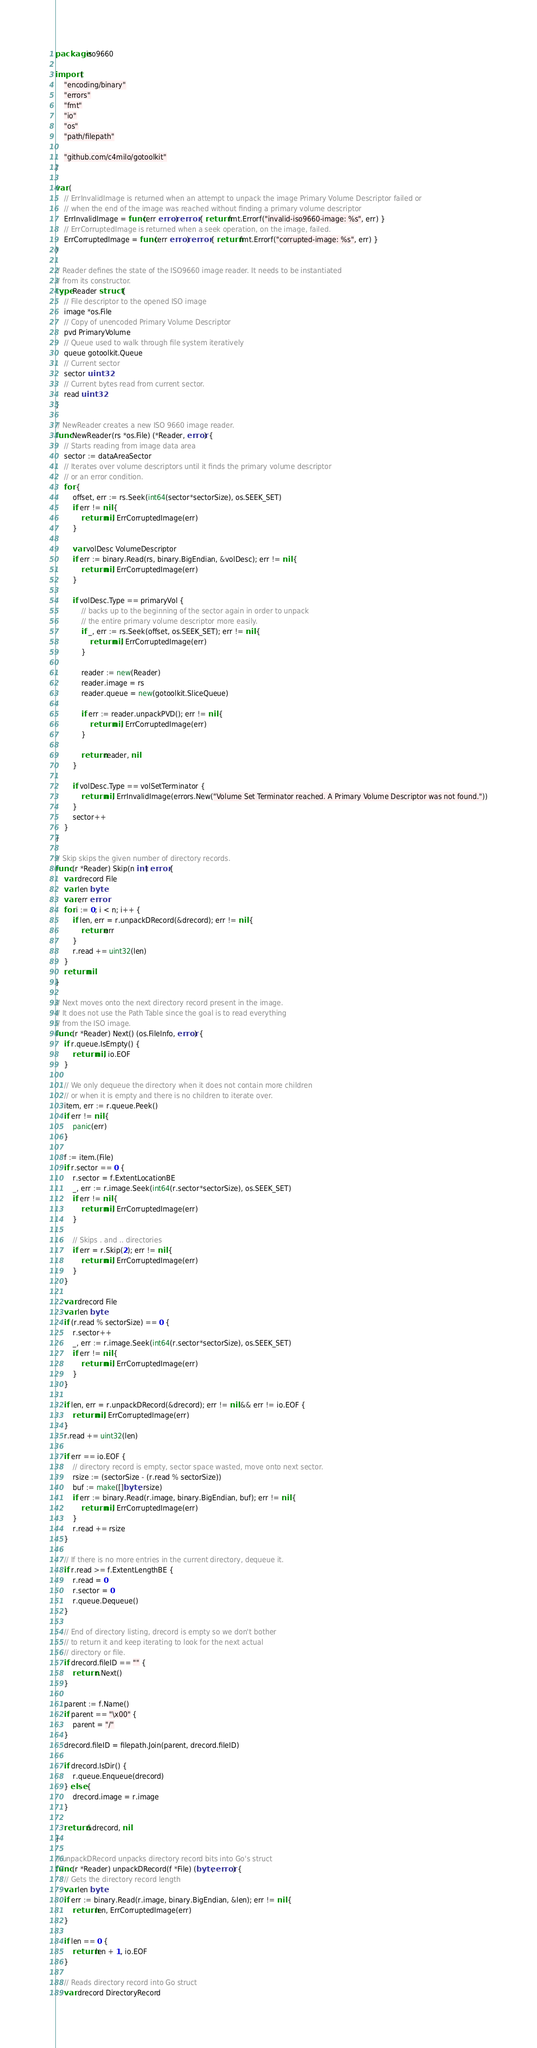Convert code to text. <code><loc_0><loc_0><loc_500><loc_500><_Go_>package iso9660

import (
	"encoding/binary"
	"errors"
	"fmt"
	"io"
	"os"
	"path/filepath"

	"github.com/c4milo/gotoolkit"
)

var (
	// ErrInvalidImage is returned when an attempt to unpack the image Primary Volume Descriptor failed or
	// when the end of the image was reached without finding a primary volume descriptor
	ErrInvalidImage = func(err error) error { return fmt.Errorf("invalid-iso9660-image: %s", err) }
	// ErrCorruptedImage is returned when a seek operation, on the image, failed.
	ErrCorruptedImage = func(err error) error { return fmt.Errorf("corrupted-image: %s", err) }
)

// Reader defines the state of the ISO9660 image reader. It needs to be instantiated
// from its constructor.
type Reader struct {
	// File descriptor to the opened ISO image
	image *os.File
	// Copy of unencoded Primary Volume Descriptor
	pvd PrimaryVolume
	// Queue used to walk through file system iteratively
	queue gotoolkit.Queue
	// Current sector
	sector uint32
	// Current bytes read from current sector.
	read uint32
}

// NewReader creates a new ISO 9660 image reader.
func NewReader(rs *os.File) (*Reader, error) {
	// Starts reading from image data area
	sector := dataAreaSector
	// Iterates over volume descriptors until it finds the primary volume descriptor
	// or an error condition.
	for {
		offset, err := rs.Seek(int64(sector*sectorSize), os.SEEK_SET)
		if err != nil {
			return nil, ErrCorruptedImage(err)
		}

		var volDesc VolumeDescriptor
		if err := binary.Read(rs, binary.BigEndian, &volDesc); err != nil {
			return nil, ErrCorruptedImage(err)
		}

		if volDesc.Type == primaryVol {
			// backs up to the beginning of the sector again in order to unpack
			// the entire primary volume descriptor more easily.
			if _, err := rs.Seek(offset, os.SEEK_SET); err != nil {
				return nil, ErrCorruptedImage(err)
			}

			reader := new(Reader)
			reader.image = rs
			reader.queue = new(gotoolkit.SliceQueue)

			if err := reader.unpackPVD(); err != nil {
				return nil, ErrCorruptedImage(err)
			}

			return reader, nil
		}

		if volDesc.Type == volSetTerminator {
			return nil, ErrInvalidImage(errors.New("Volume Set Terminator reached. A Primary Volume Descriptor was not found."))
		}
		sector++
	}
}

// Skip skips the given number of directory records.
func (r *Reader) Skip(n int) error {
	var drecord File
	var len byte
	var err error
	for i := 0; i < n; i++ {
		if len, err = r.unpackDRecord(&drecord); err != nil {
			return err
		}
		r.read += uint32(len)
	}
	return nil
}

// Next moves onto the next directory record present in the image.
// It does not use the Path Table since the goal is to read everything
// from the ISO image.
func (r *Reader) Next() (os.FileInfo, error) {
	if r.queue.IsEmpty() {
		return nil, io.EOF
	}

	// We only dequeue the directory when it does not contain more children
	// or when it is empty and there is no children to iterate over.
	item, err := r.queue.Peek()
	if err != nil {
		panic(err)
	}

	f := item.(File)
	if r.sector == 0 {
		r.sector = f.ExtentLocationBE
		_, err := r.image.Seek(int64(r.sector*sectorSize), os.SEEK_SET)
		if err != nil {
			return nil, ErrCorruptedImage(err)
		}

		// Skips . and .. directories
		if err = r.Skip(2); err != nil {
			return nil, ErrCorruptedImage(err)
		}
	}

	var drecord File
	var len byte
	if (r.read % sectorSize) == 0 {
		r.sector++
		_, err := r.image.Seek(int64(r.sector*sectorSize), os.SEEK_SET)
		if err != nil {
			return nil, ErrCorruptedImage(err)
		}
	}

	if len, err = r.unpackDRecord(&drecord); err != nil && err != io.EOF {
		return nil, ErrCorruptedImage(err)
	}
	r.read += uint32(len)

	if err == io.EOF {
		// directory record is empty, sector space wasted, move onto next sector.
		rsize := (sectorSize - (r.read % sectorSize))
		buf := make([]byte, rsize)
		if err := binary.Read(r.image, binary.BigEndian, buf); err != nil {
			return nil, ErrCorruptedImage(err)
		}
		r.read += rsize
	}

	// If there is no more entries in the current directory, dequeue it.
	if r.read >= f.ExtentLengthBE {
		r.read = 0
		r.sector = 0
		r.queue.Dequeue()
	}

	// End of directory listing, drecord is empty so we don't bother
	// to return it and keep iterating to look for the next actual
	// directory or file.
	if drecord.fileID == "" {
		return r.Next()
	}

	parent := f.Name()
	if parent == "\x00" {
		parent = "/"
	}
	drecord.fileID = filepath.Join(parent, drecord.fileID)

	if drecord.IsDir() {
		r.queue.Enqueue(drecord)
	} else {
		drecord.image = r.image
	}

	return &drecord, nil
}

// unpackDRecord unpacks directory record bits into Go's struct
func (r *Reader) unpackDRecord(f *File) (byte, error) {
	// Gets the directory record length
	var len byte
	if err := binary.Read(r.image, binary.BigEndian, &len); err != nil {
		return len, ErrCorruptedImage(err)
	}

	if len == 0 {
		return len + 1, io.EOF
	}

	// Reads directory record into Go struct
	var drecord DirectoryRecord</code> 